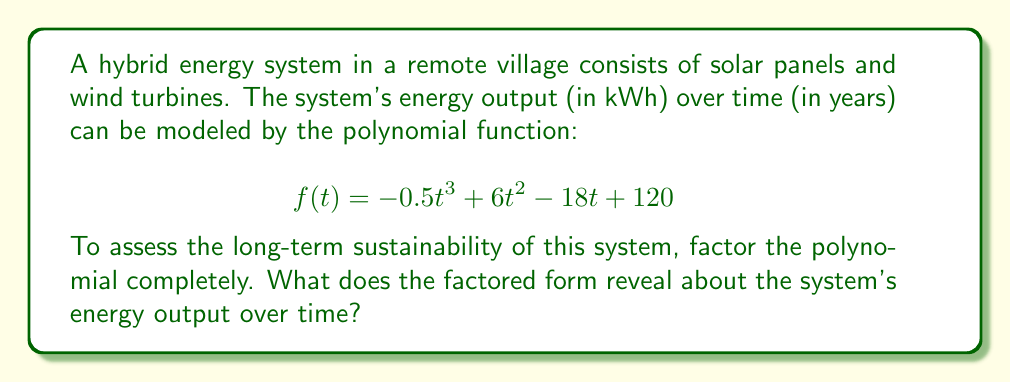Can you solve this math problem? Let's approach this step-by-step:

1) First, we need to factor out the greatest common factor (GCF):
   $$f(t) = -0.5t^3 + 6t^2 - 18t + 120$$
   $$f(t) = -0.5(t^3 - 12t^2 + 36t - 240)$$

2) Now, let's try to identify a factor. By inspection or using the rational root theorem, we can find that $(t - 6)$ is a factor:
   $$-0.5(t^3 - 12t^2 + 36t - 240) = -0.5(t - 6)(t^2 - 6t + 40)$$

3) The quadratic factor $t^2 - 6t + 40$ can be factored further:
   $$t^2 - 6t + 40 = (t - 4)(t - 2)$$

4) Therefore, the completely factored form is:
   $$f(t) = -0.5(t - 6)(t - 4)(t - 2)$$

5) Interpretation:
   - The function has roots at $t = 2$, $t = 4$, and $t = 6$ years.
   - The negative coefficient $-0.5$ indicates that the function is negative for $t > 6$, positive for $4 < t < 6$, negative for $2 < t < 4$, and positive for $t < 2$.
   - This suggests that the energy output will be zero at 2, 4, and 6 years, and will alternate between positive and negative values in between these points.
   - The negative values after 6 years indicate that the system will require more energy input than it produces in the long term, suggesting it's not sustainable beyond 6 years without intervention or upgrades.
Answer: $f(t) = -0.5(t - 6)(t - 4)(t - 2)$; System unsustainable after 6 years. 